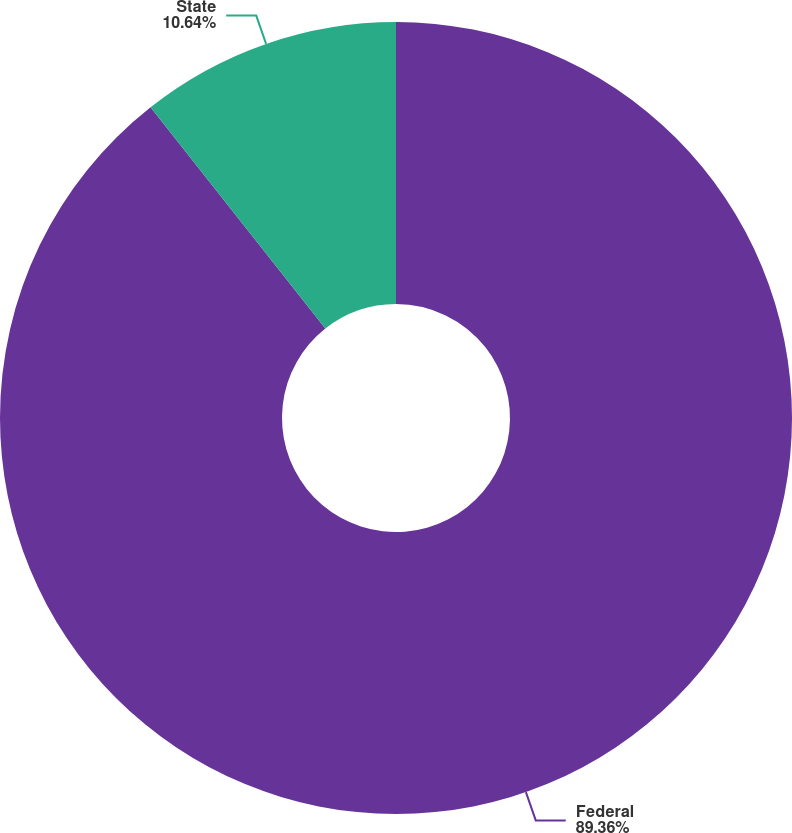Convert chart to OTSL. <chart><loc_0><loc_0><loc_500><loc_500><pie_chart><fcel>Federal<fcel>State<nl><fcel>89.36%<fcel>10.64%<nl></chart> 